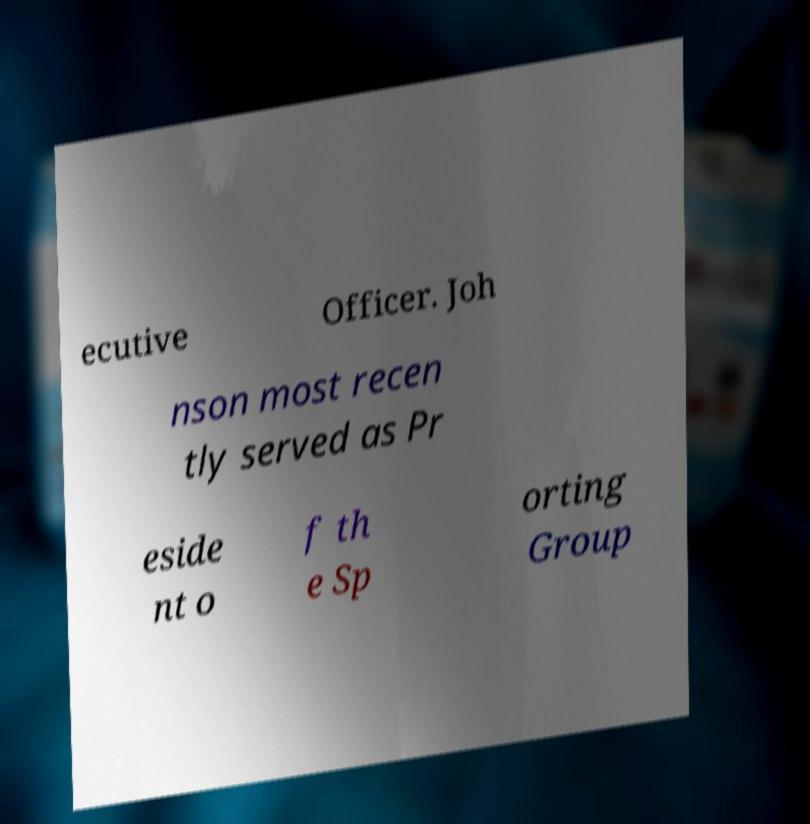Please identify and transcribe the text found in this image. ecutive Officer. Joh nson most recen tly served as Pr eside nt o f th e Sp orting Group 